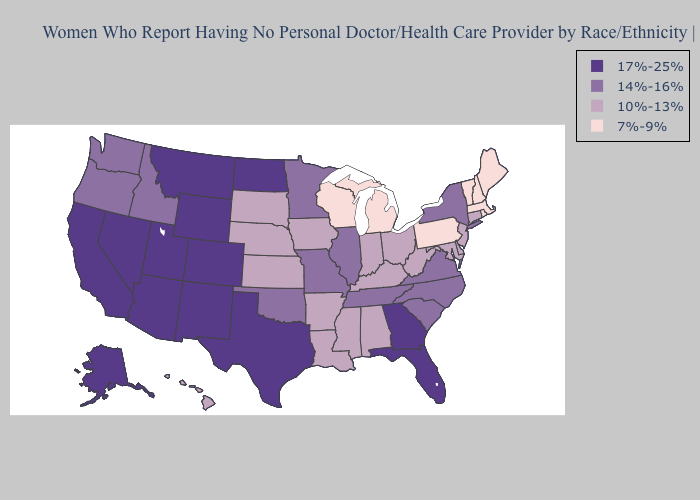Among the states that border Texas , which have the highest value?
Write a very short answer. New Mexico. Does Vermont have the lowest value in the Northeast?
Write a very short answer. Yes. Does Michigan have the highest value in the MidWest?
Answer briefly. No. Which states hav the highest value in the West?
Give a very brief answer. Alaska, Arizona, California, Colorado, Montana, Nevada, New Mexico, Utah, Wyoming. What is the value of Nevada?
Write a very short answer. 17%-25%. What is the highest value in states that border Minnesota?
Short answer required. 17%-25%. Does Georgia have the highest value in the USA?
Write a very short answer. Yes. What is the highest value in the Northeast ?
Quick response, please. 14%-16%. Among the states that border Washington , which have the highest value?
Answer briefly. Idaho, Oregon. Does the first symbol in the legend represent the smallest category?
Quick response, please. No. Name the states that have a value in the range 14%-16%?
Concise answer only. Idaho, Illinois, Minnesota, Missouri, New York, North Carolina, Oklahoma, Oregon, South Carolina, Tennessee, Virginia, Washington. Name the states that have a value in the range 7%-9%?
Write a very short answer. Maine, Massachusetts, Michigan, New Hampshire, Pennsylvania, Rhode Island, Vermont, Wisconsin. What is the value of Michigan?
Be succinct. 7%-9%. Does Michigan have the same value as Tennessee?
Give a very brief answer. No. 